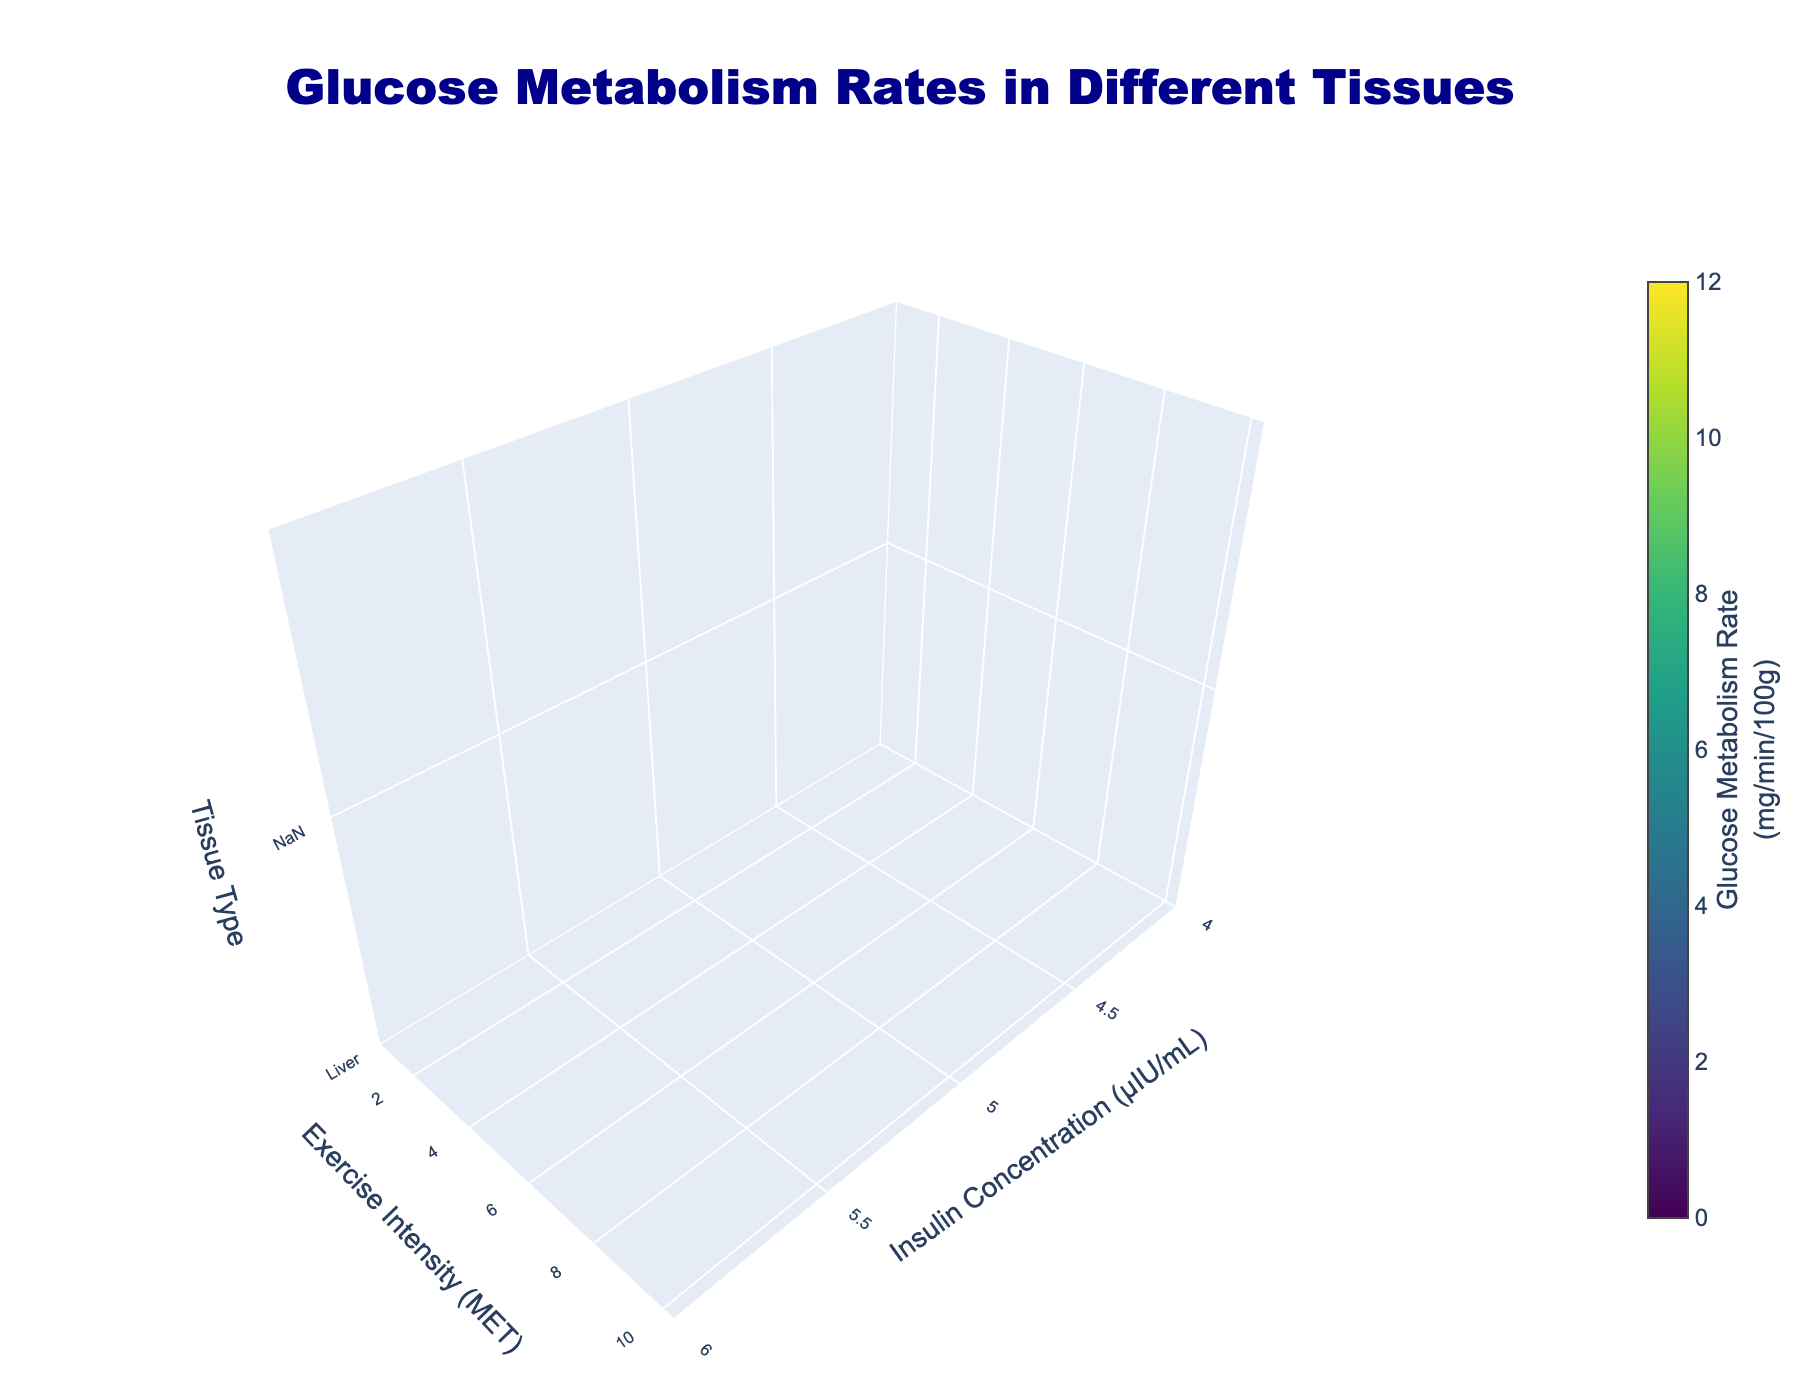What is the title of the plot? The title of the plot is displayed prominently at the top of the figure.
Answer: Glucose Metabolism Rates in Different Tissues Which axis represents the Insulin Concentration? The x-axis label indicates that it represents the Insulin Concentration in μIU/mL.
Answer: x-axis Which tissue type shows the lowest glucose metabolism rate at the lowest exercise intensity and insulin concentration? The 3D volume plot shows the color-coded glucose metabolism rates, and by observing the color for the lowest values at the low insulin concentration and exercise intensity, Adipose Tissue shows the lowest rate.
Answer: Adipose Tissue How does the glucose metabolism rate of Skeletal Muscle change with increasing insulin concentration at a fixed exercise intensity of 10 MET? By following the trajectory of the Skeletal Muscle tissue type along increasing insulin concentration values while keeping exercise intensity at 10 MET, it shows an increasing trend in glucose metabolism rates.
Answer: Increases Compare the glucose metabolism rates between Skeletal Muscle and Adipose Tissue at an insulin concentration of 20 μIU/mL and exercise intensity of 5 MET. Which is higher? The color corresponding to the given points for Skeletal Muscle is more intense than that of Adipose Tissue, indicating a higher glucose metabolism rate for Skeletal Muscle.
Answer: Skeletal Muscle Which tissue exhibits the highest glucose metabolism rate overall, and what is the rate? The plot's color coding for the value axis (color map) will show the maximum value; Skeletal Muscle shows the highest glucose metabolism rate at 12.5 mg/min/100g.
Answer: Skeletal Muscle, 12.5 mg/min/100g What happens to the glucose metabolism rate in the liver when the exercise intensity changes from 1 MET to 10 MET at a fixed insulin concentration of 10 μIU/mL? Observing the plot for the liver tissue type along the exercise intensity dimension for the insulin concentration of 10 μIU/mL shows an increase in glucose metabolism rates from lower to higher intensity.
Answer: Increases Which tissue has the lowest glucose metabolism rate at an insulin concentration of 10 μIU/mL and exercise intensity of 5 MET? By comparing the colors at the given points for all tissue types, Adipose Tissue has the lowest intensity color, indicating the lowest glucose metabolism rate.
Answer: Adipose Tissue What's the difference in glucose metabolism rates between Liver and Adipose Tissue at an insulin concentration of 5 μIU/mL and exercise intensity of 1 MET? By noting the specific values from the plot at these coordinates for both tissue types, the difference is obtained as 3.2 mg/min/100g (Liver) - 0.8 mg/min/100g (Adipose Tissue) = 2.4 mg/min/100g.
Answer: 2.4 mg/min/100g 